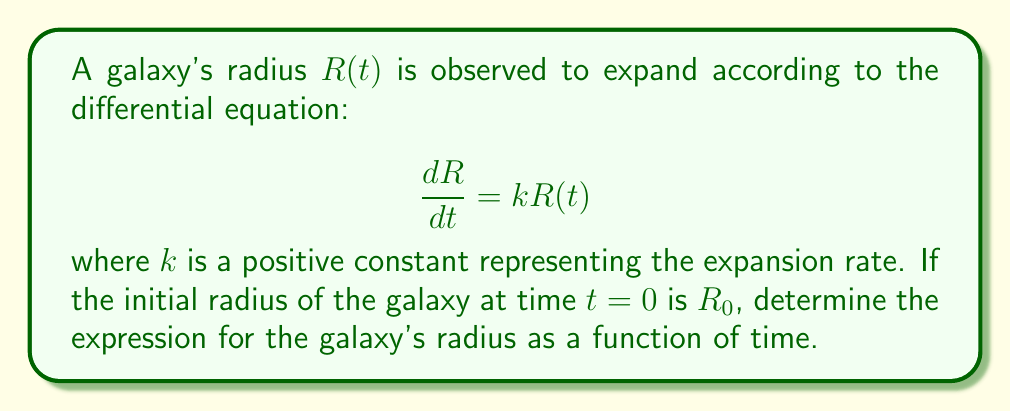Give your solution to this math problem. To solve this first-order differential equation, we can follow these steps:

1) First, we recognize this as a separable differential equation. We can separate the variables:

   $$\frac{dR}{R} = k dt$$

2) Now, we integrate both sides:

   $$\int \frac{dR}{R} = \int k dt$$

3) This gives us:

   $$\ln|R| = kt + C$$

   where $C$ is a constant of integration.

4) We can now exponentiate both sides:

   $$R = e^{kt + C} = e^C e^{kt}$$

5) Let's call $e^C = A$, so we have:

   $$R(t) = A e^{kt}$$

6) To determine $A$, we can use the initial condition. At $t=0$, $R(0) = R_0$:

   $$R_0 = A e^{k(0)} = A$$

7) Therefore, our final solution is:

   $$R(t) = R_0 e^{kt}$$

This equation describes the radius of the galaxy as an exponential function of time, with the initial radius $R_0$ and expansion rate $k$.
Answer: $$R(t) = R_0 e^{kt}$$ 